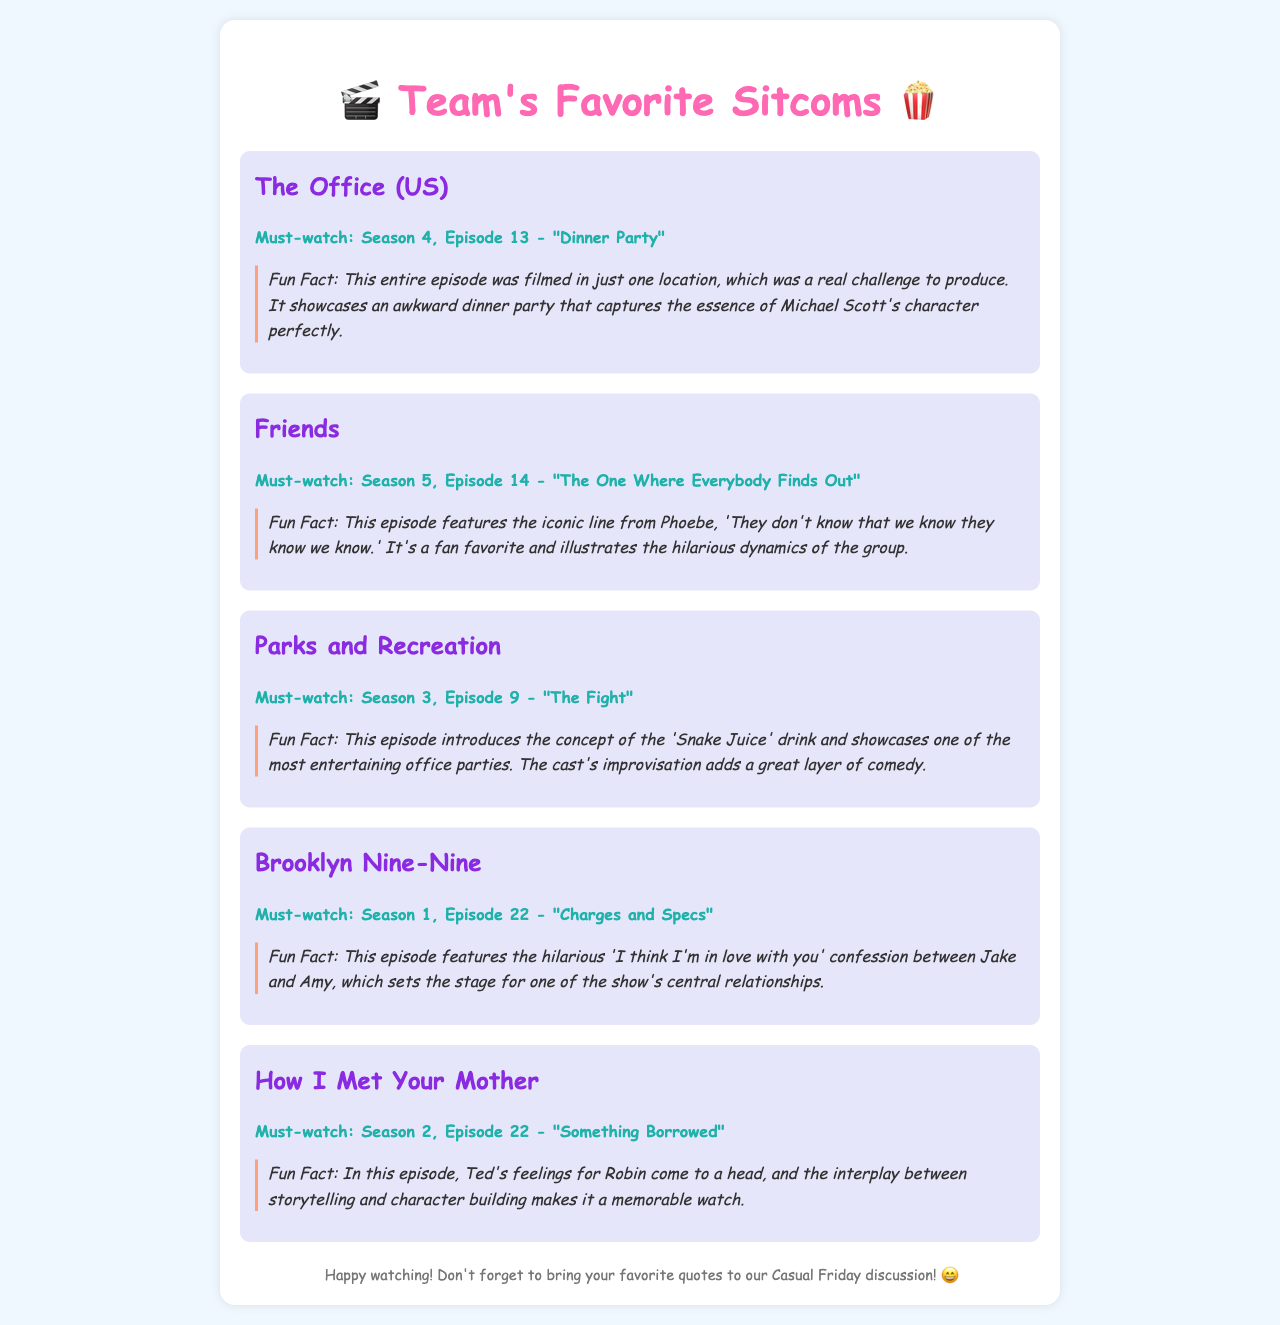What is the title of the first sitcom mentioned? The first sitcom listed in the document is "The Office (US)," which is the first entry in the memo.
Answer: The Office (US) Which episode of Friends is recommended? The document specifies that Season 5, Episode 14 of Friends, titled "The One Where Everybody Finds Out," is a must-watch.
Answer: Season 5, Episode 14 - "The One Where Everybody Finds Out" What is the fun fact about "Dinner Party"? The fun fact states that the entire "Dinner Party" episode was filmed in just one location, which posed challenges for production.
Answer: Filmed in just one location How many sitcoms are discussed in total? The document lists five different sitcoms, making up the total count of entries.
Answer: Five Which character's quote is featured in Friends? The document includes a famous quote from Phoebe in Friends, highlighting a specific humorous moment.
Answer: "They don't know that we know they know we know." What drink concept is introduced in Parks and Recreation? The document discusses the episode where 'Snake Juice' is introduced, which adds a humorous element to the party.
Answer: Snake Juice Which sitcom is associated with Jake and Amy's confession? The question refers to Brooklyn Nine-Nine, where Jake expresses his feelings towards Amy in a specific episode.
Answer: Brooklyn Nine-Nine What theme is prominent in How I Met Your Mother's recommended episode? The document indicates that the interplay between storytelling and character building is a notable theme in the mentioned HIMYM episode.
Answer: Storytelling and character building 